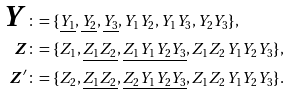Convert formula to latex. <formula><loc_0><loc_0><loc_500><loc_500>\boldsymbol Y & \colon = \{ \underline { Y _ { 1 } } , \underline { Y _ { 2 } } , \underline { Y _ { 3 } } , Y _ { 1 } Y _ { 2 } , Y _ { 1 } Y _ { 3 } , Y _ { 2 } Y _ { 3 } \} , \\ \boldsymbol Z & \colon = \{ Z _ { 1 } , \underline { Z _ { 1 } Z _ { 2 } } , \underline { Z _ { 1 } Y _ { 1 } Y _ { 2 } Y _ { 3 } } , Z _ { 1 } Z _ { 2 } Y _ { 1 } Y _ { 2 } Y _ { 3 } \} , \\ \boldsymbol Z ^ { \prime } & \colon = \{ Z _ { 2 } , \underline { Z _ { 1 } Z _ { 2 } } , \underline { Z _ { 2 } Y _ { 1 } Y _ { 2 } Y _ { 3 } } , Z _ { 1 } Z _ { 2 } Y _ { 1 } Y _ { 2 } Y _ { 3 } \} .</formula> 